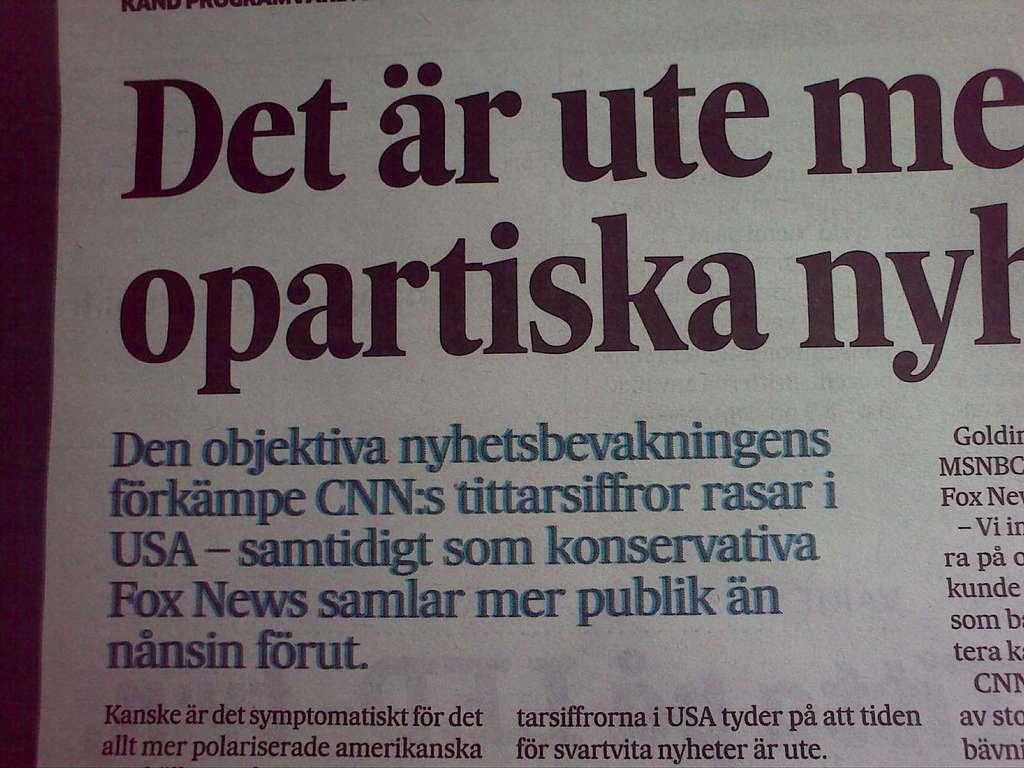<image>
Give a short and clear explanation of the subsequent image. The headline of this article begins with the word "det". 